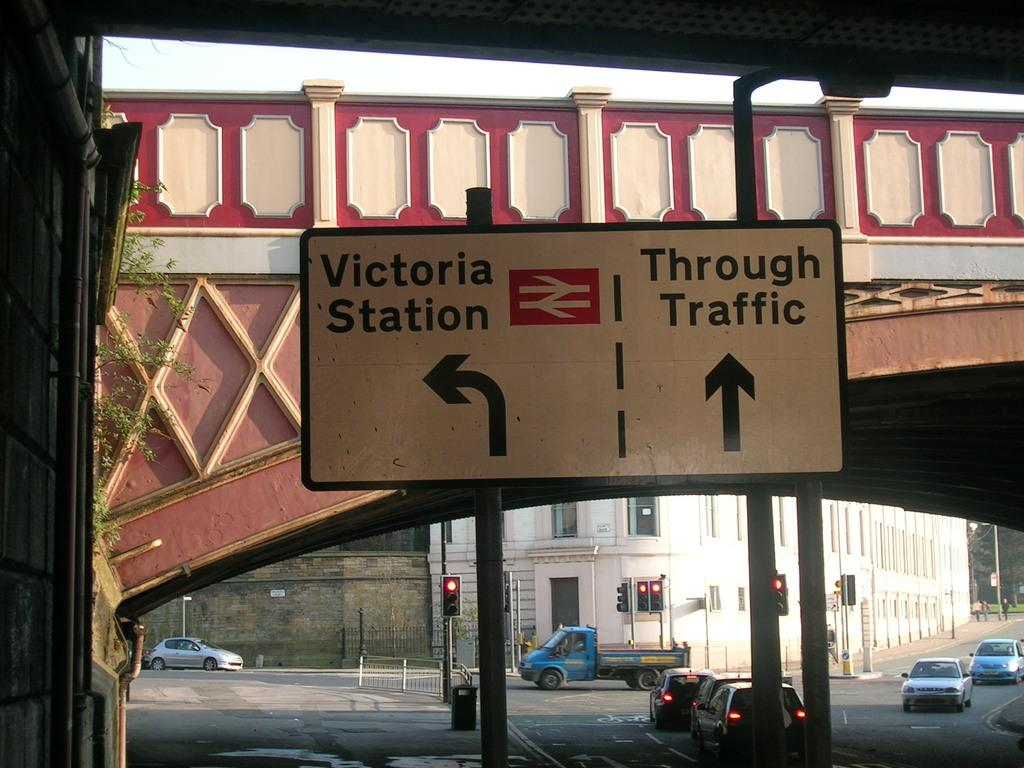<image>
Give a short and clear explanation of the subsequent image. a road sign that says 'victoria station' on the left and 'through traffic' on the right 